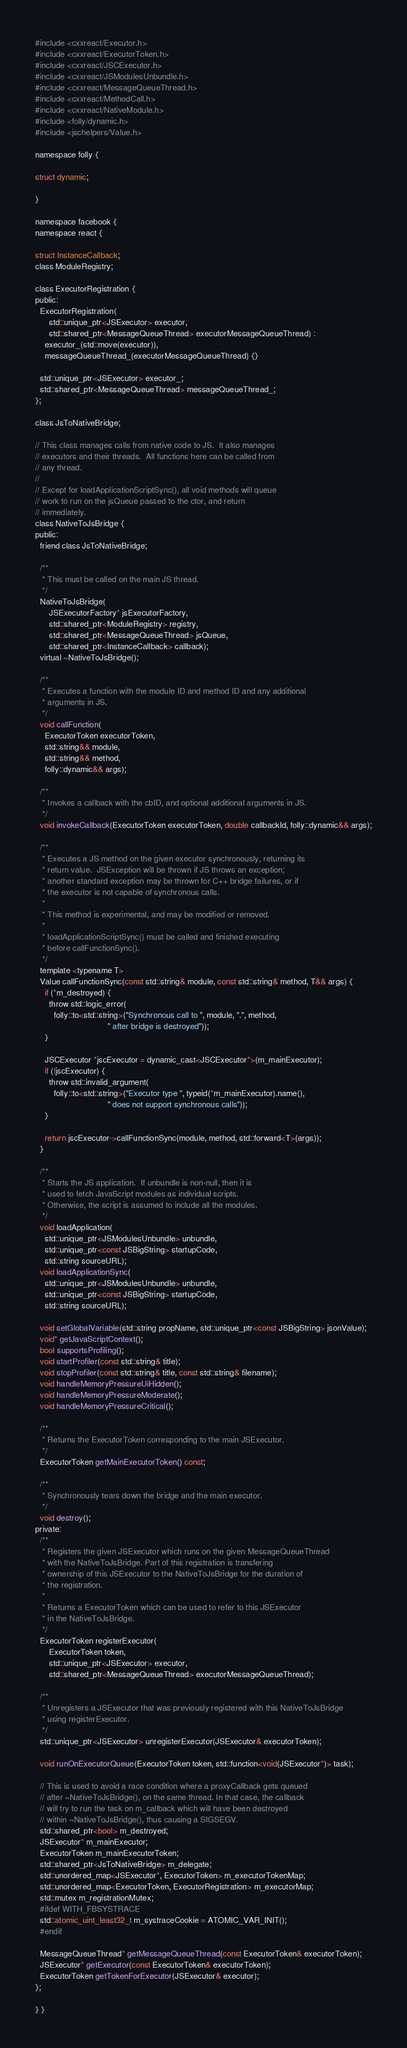Convert code to text. <code><loc_0><loc_0><loc_500><loc_500><_C_>#include <cxxreact/Executor.h>
#include <cxxreact/ExecutorToken.h>
#include <cxxreact/JSCExecutor.h>
#include <cxxreact/JSModulesUnbundle.h>
#include <cxxreact/MessageQueueThread.h>
#include <cxxreact/MethodCall.h>
#include <cxxreact/NativeModule.h>
#include <folly/dynamic.h>
#include <jschelpers/Value.h>

namespace folly {

struct dynamic;

}

namespace facebook {
namespace react {

struct InstanceCallback;
class ModuleRegistry;

class ExecutorRegistration {
public:
  ExecutorRegistration(
      std::unique_ptr<JSExecutor> executor,
      std::shared_ptr<MessageQueueThread> executorMessageQueueThread) :
    executor_(std::move(executor)),
    messageQueueThread_(executorMessageQueueThread) {}

  std::unique_ptr<JSExecutor> executor_;
  std::shared_ptr<MessageQueueThread> messageQueueThread_;
};

class JsToNativeBridge;

// This class manages calls from native code to JS.  It also manages
// executors and their threads.  All functions here can be called from
// any thread.
//
// Except for loadApplicationScriptSync(), all void methods will queue
// work to run on the jsQueue passed to the ctor, and return
// immediately.
class NativeToJsBridge {
public:
  friend class JsToNativeBridge;

  /**
   * This must be called on the main JS thread.
   */
  NativeToJsBridge(
      JSExecutorFactory* jsExecutorFactory,
      std::shared_ptr<ModuleRegistry> registry,
      std::shared_ptr<MessageQueueThread> jsQueue,
      std::shared_ptr<InstanceCallback> callback);
  virtual ~NativeToJsBridge();

  /**
   * Executes a function with the module ID and method ID and any additional
   * arguments in JS.
   */
  void callFunction(
    ExecutorToken executorToken,
    std::string&& module,
    std::string&& method,
    folly::dynamic&& args);

  /**
   * Invokes a callback with the cbID, and optional additional arguments in JS.
   */
  void invokeCallback(ExecutorToken executorToken, double callbackId, folly::dynamic&& args);

  /**
   * Executes a JS method on the given executor synchronously, returning its
   * return value.  JSException will be thrown if JS throws an exception;
   * another standard exception may be thrown for C++ bridge failures, or if
   * the executor is not capable of synchronous calls.
   *
   * This method is experimental, and may be modified or removed.
   *
   * loadApplicationScriptSync() must be called and finished executing
   * before callFunctionSync().
   */
  template <typename T>
  Value callFunctionSync(const std::string& module, const std::string& method, T&& args) {
    if (*m_destroyed) {
      throw std::logic_error(
        folly::to<std::string>("Synchronous call to ", module, ".", method,
                               " after bridge is destroyed"));
    }

    JSCExecutor *jscExecutor = dynamic_cast<JSCExecutor*>(m_mainExecutor);
    if (!jscExecutor) {
      throw std::invalid_argument(
        folly::to<std::string>("Executor type ", typeid(*m_mainExecutor).name(),
                               " does not support synchronous calls"));
    }

    return jscExecutor->callFunctionSync(module, method, std::forward<T>(args));
  }

  /**
   * Starts the JS application.  If unbundle is non-null, then it is
   * used to fetch JavaScript modules as individual scripts.
   * Otherwise, the script is assumed to include all the modules.
   */
  void loadApplication(
    std::unique_ptr<JSModulesUnbundle> unbundle,
    std::unique_ptr<const JSBigString> startupCode,
    std::string sourceURL);
  void loadApplicationSync(
    std::unique_ptr<JSModulesUnbundle> unbundle,
    std::unique_ptr<const JSBigString> startupCode,
    std::string sourceURL);

  void setGlobalVariable(std::string propName, std::unique_ptr<const JSBigString> jsonValue);
  void* getJavaScriptContext();
  bool supportsProfiling();
  void startProfiler(const std::string& title);
  void stopProfiler(const std::string& title, const std::string& filename);
  void handleMemoryPressureUiHidden();
  void handleMemoryPressureModerate();
  void handleMemoryPressureCritical();

  /**
   * Returns the ExecutorToken corresponding to the main JSExecutor.
   */
  ExecutorToken getMainExecutorToken() const;

  /**
   * Synchronously tears down the bridge and the main executor.
   */
  void destroy();
private:
  /**
   * Registers the given JSExecutor which runs on the given MessageQueueThread
   * with the NativeToJsBridge. Part of this registration is transfering
   * ownership of this JSExecutor to the NativeToJsBridge for the duration of
   * the registration.
   *
   * Returns a ExecutorToken which can be used to refer to this JSExecutor
   * in the NativeToJsBridge.
   */
  ExecutorToken registerExecutor(
      ExecutorToken token,
      std::unique_ptr<JSExecutor> executor,
      std::shared_ptr<MessageQueueThread> executorMessageQueueThread);

  /**
   * Unregisters a JSExecutor that was previously registered with this NativeToJsBridge
   * using registerExecutor.
   */
  std::unique_ptr<JSExecutor> unregisterExecutor(JSExecutor& executorToken);

  void runOnExecutorQueue(ExecutorToken token, std::function<void(JSExecutor*)> task);

  // This is used to avoid a race condition where a proxyCallback gets queued
  // after ~NativeToJsBridge(), on the same thread. In that case, the callback
  // will try to run the task on m_callback which will have been destroyed
  // within ~NativeToJsBridge(), thus causing a SIGSEGV.
  std::shared_ptr<bool> m_destroyed;
  JSExecutor* m_mainExecutor;
  ExecutorToken m_mainExecutorToken;
  std::shared_ptr<JsToNativeBridge> m_delegate;
  std::unordered_map<JSExecutor*, ExecutorToken> m_executorTokenMap;
  std::unordered_map<ExecutorToken, ExecutorRegistration> m_executorMap;
  std::mutex m_registrationMutex;
  #ifdef WITH_FBSYSTRACE
  std::atomic_uint_least32_t m_systraceCookie = ATOMIC_VAR_INIT();
  #endif

  MessageQueueThread* getMessageQueueThread(const ExecutorToken& executorToken);
  JSExecutor* getExecutor(const ExecutorToken& executorToken);
  ExecutorToken getTokenForExecutor(JSExecutor& executor);
};

} }
</code> 